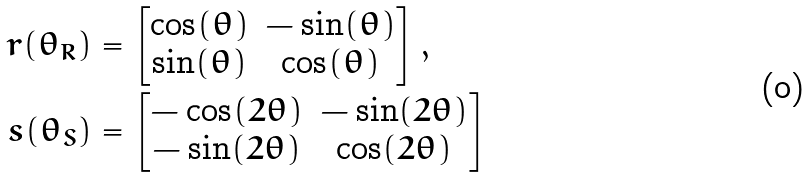Convert formula to latex. <formula><loc_0><loc_0><loc_500><loc_500>r ( \theta _ { R } ) & = \begin{bmatrix} \cos ( \theta ) & - \sin ( \theta ) \\ \sin ( \theta ) & \cos ( \theta ) \end{bmatrix} , \\ s ( \theta _ { S } ) & = \begin{bmatrix} - \cos ( 2 \theta ) & - \sin ( 2 \theta ) \\ - \sin ( 2 \theta ) & \cos ( 2 \theta ) \end{bmatrix}</formula> 